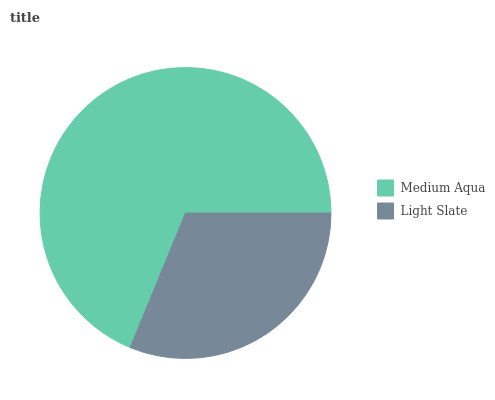Is Light Slate the minimum?
Answer yes or no. Yes. Is Medium Aqua the maximum?
Answer yes or no. Yes. Is Light Slate the maximum?
Answer yes or no. No. Is Medium Aqua greater than Light Slate?
Answer yes or no. Yes. Is Light Slate less than Medium Aqua?
Answer yes or no. Yes. Is Light Slate greater than Medium Aqua?
Answer yes or no. No. Is Medium Aqua less than Light Slate?
Answer yes or no. No. Is Medium Aqua the high median?
Answer yes or no. Yes. Is Light Slate the low median?
Answer yes or no. Yes. Is Light Slate the high median?
Answer yes or no. No. Is Medium Aqua the low median?
Answer yes or no. No. 